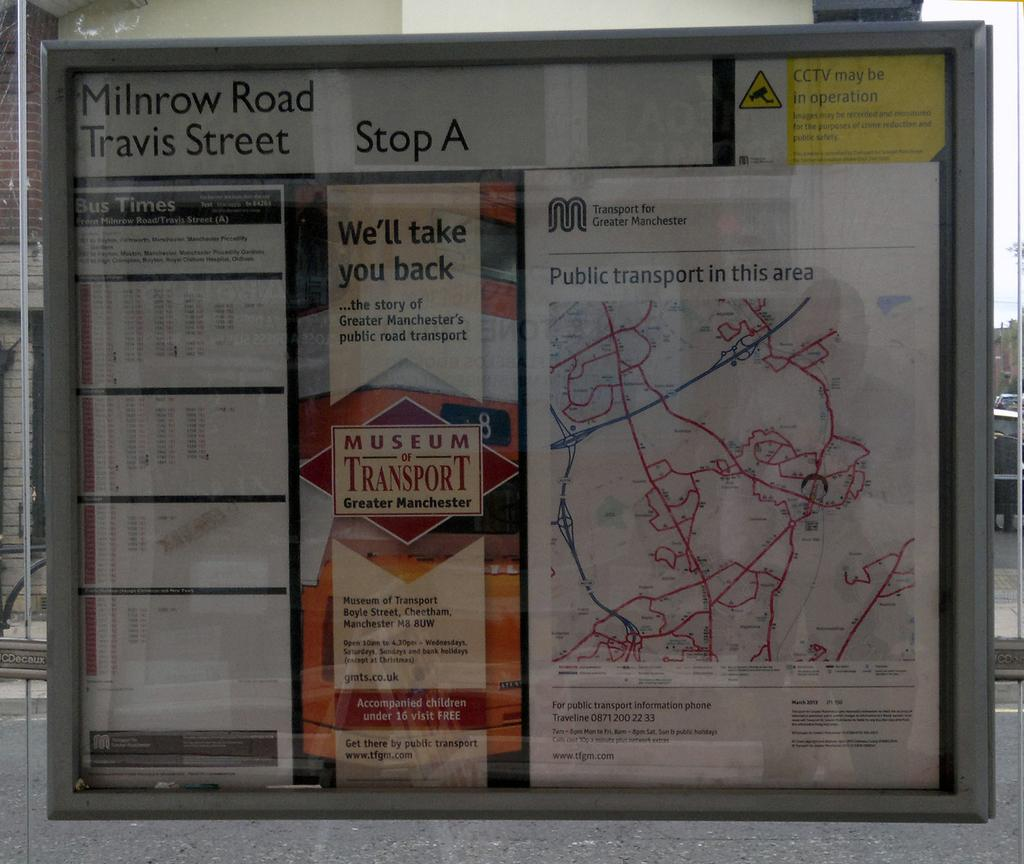<image>
Provide a brief description of the given image. Milnrow Road and Travis Street are at Stop A on the map of Greater Manchester. 